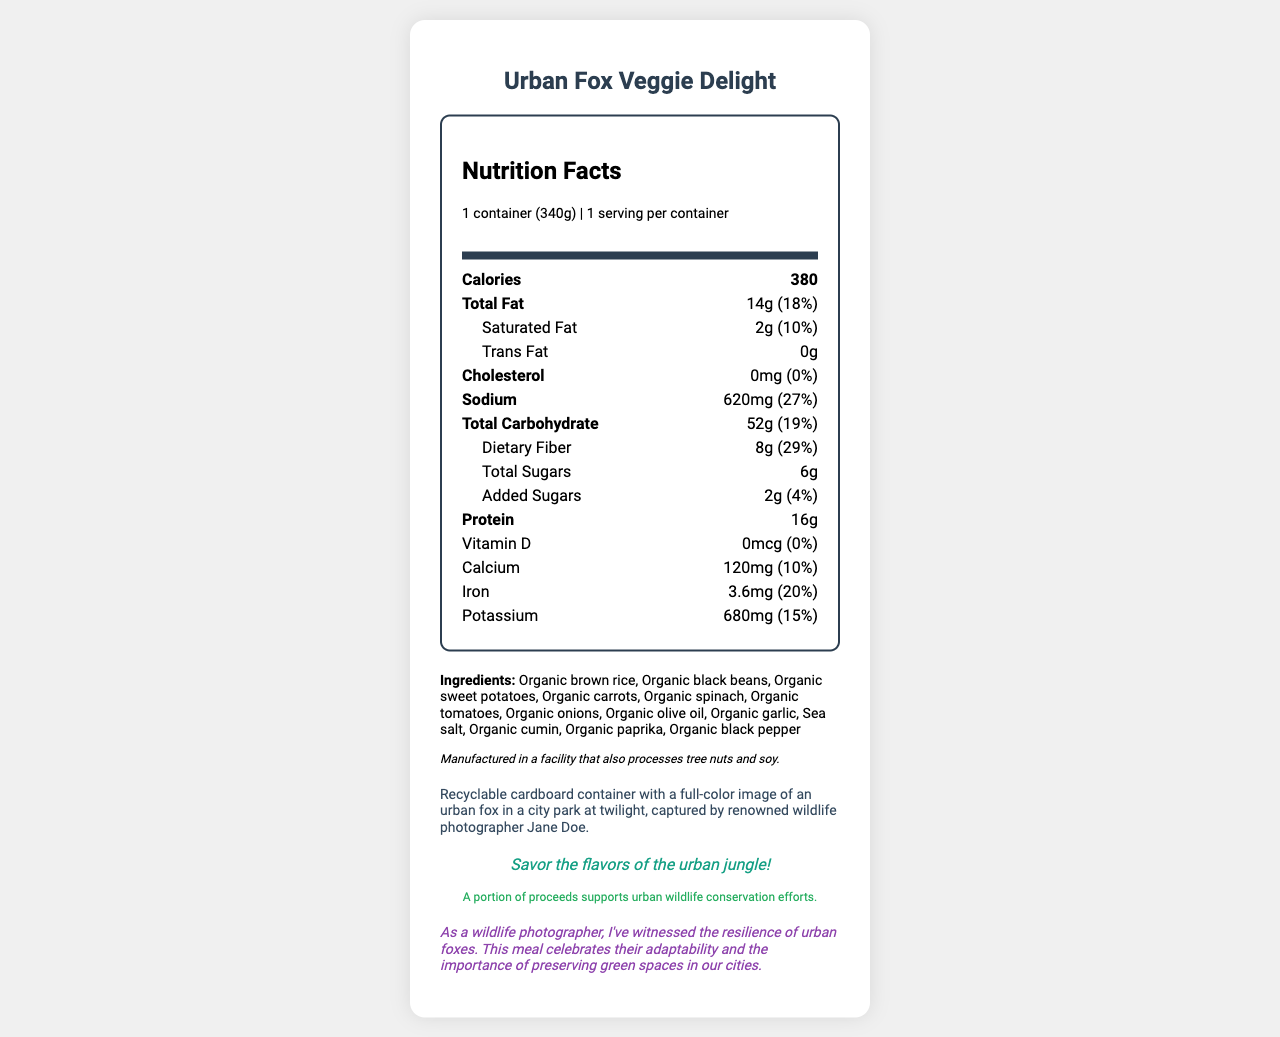what is the serving size? The document lists the serving size as "1 container (340g)" in the nutrition facts section.
Answer: 1 container (340g) how many grams of dietary fiber are in the Urban Fox Veggie Delight? The dietary fiber content is indicated as 8g.
Answer: 8g what percentage of the daily value is the sodium content? The sodium content is listed as "620mg (27%)" in the document.
Answer: 27% which ingredient is not organic? All other ingredients in the list have the prefix "Organic," but sea salt does not.
Answer: Sea salt how many calories are in one serving? The document shows that each serving contains 380 calories.
Answer: 380 calories how much protein does the meal contain? The nutrition label shows that the meal contains 16g of protein.
Answer: 16g which ingredients are used in this meal? A. Organic brown rice, Organic black beans, Sea salt B. Chicken, Organic olive oil, Organic tomatoes C. Organic cumin, Beef, Organic onions Ingredient list contains Organic brown rice, Organic black beans, Sea salt.
Answer: A what is the total fat content, and what percentage of the daily value is it? A. 14g (10%) B. 10g (20%) C. 14g (18%) D. 18g (14%) The document states "Total Fat: 14g (18%)".
Answer: C is the meal suitable for someone avoiding cholesterol? The meal has 0mg of cholesterol, making it suitable for those avoiding cholesterol.
Answer: Yes summarize the main idea of the document. This summary captures the key points of the document, including the nutritional data, ingredients, allergen information, packaging description, and additional notes about conservation efforts.
Answer: The document is a nutrition facts label for a vegetarian frozen meal called "Urban Fox Veggie Delight," which contains information on serving size, calorie content, various nutrients, ingredients, allergen info, and the packaging description featuring an urban fox. Profits from the product support urban wildlife conservation. who is the photographer mentioned in the document? The packaging description credits Jane Doe as the renowned wildlife photographer.
Answer: Jane Doe is this meal high in dietary fiber? The meal contains 8g of dietary fiber, which is 29% of the daily value, indicating a high fiber content.
Answer: Yes does the document provide cooking instructions for the meal? The document focuses on nutritional facts and ingredient lists and does not provide cooking instructions.
Answer: Not enough information 